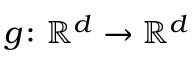Convert formula to latex. <formula><loc_0><loc_0><loc_500><loc_500>g \colon { \mathbb { R } } ^ { d } \to { \mathbb { R } } ^ { d }</formula> 